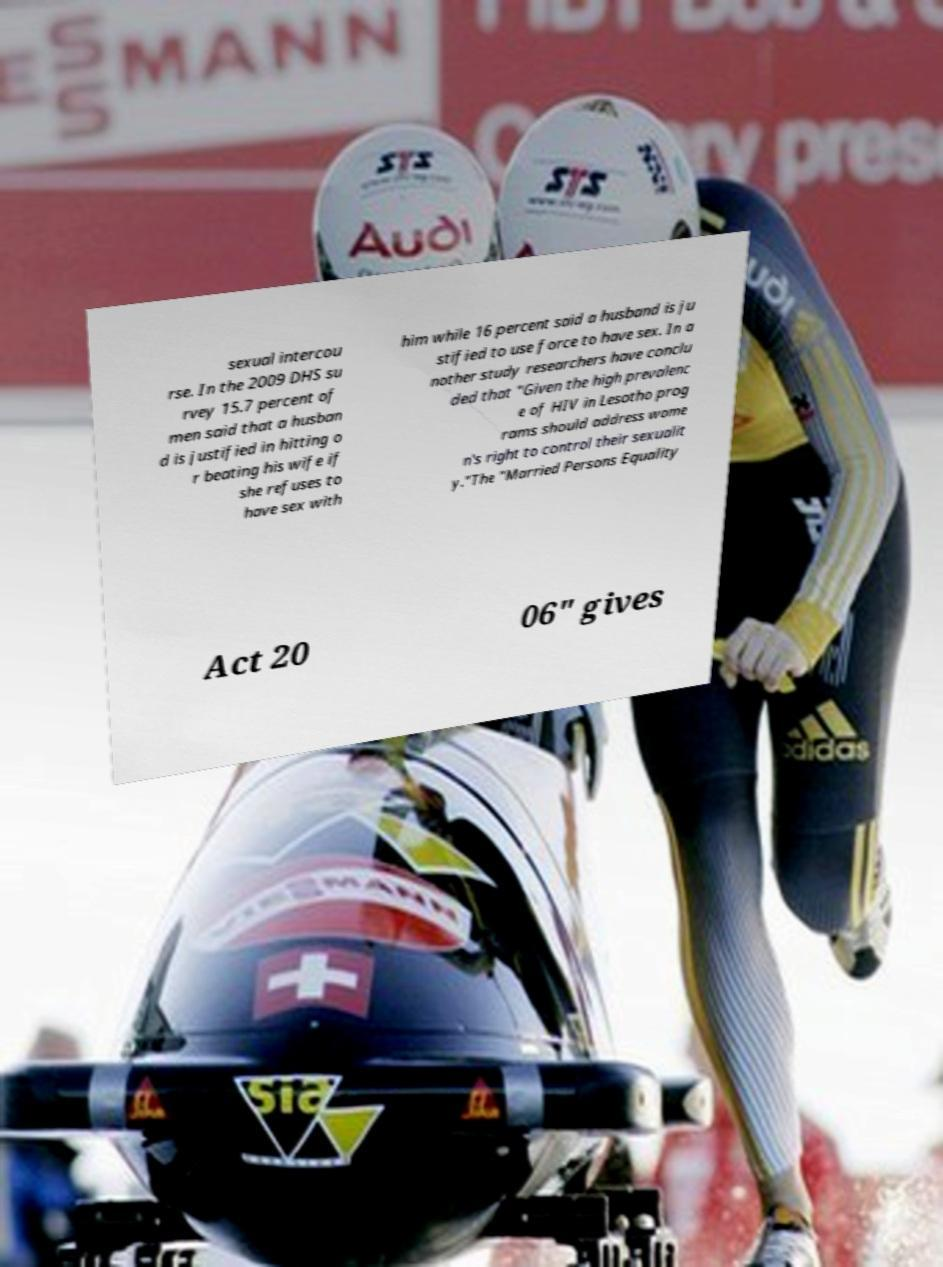Could you extract and type out the text from this image? sexual intercou rse. In the 2009 DHS su rvey 15.7 percent of men said that a husban d is justified in hitting o r beating his wife if she refuses to have sex with him while 16 percent said a husband is ju stified to use force to have sex. In a nother study researchers have conclu ded that "Given the high prevalenc e of HIV in Lesotho prog rams should address wome n's right to control their sexualit y."The "Married Persons Equality Act 20 06" gives 